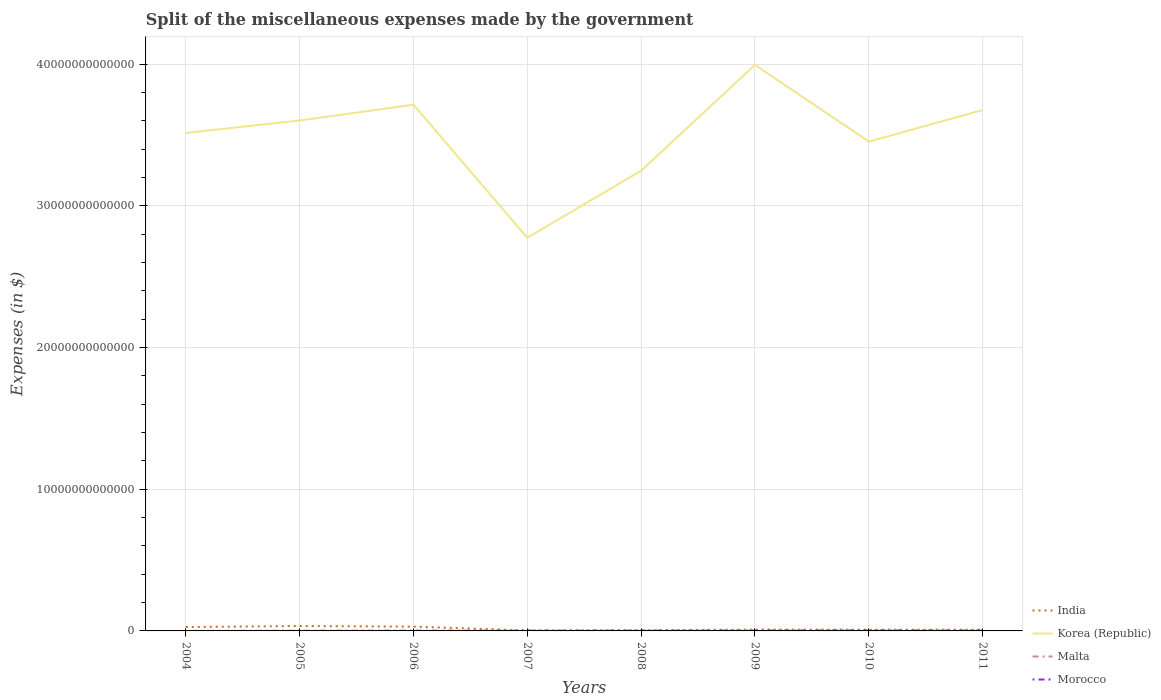How many different coloured lines are there?
Give a very brief answer. 4. Across all years, what is the maximum miscellaneous expenses made by the government in Korea (Republic)?
Give a very brief answer. 2.77e+13. In which year was the miscellaneous expenses made by the government in Korea (Republic) maximum?
Give a very brief answer. 2007. What is the total miscellaneous expenses made by the government in Malta in the graph?
Your answer should be compact. 2.40e+08. What is the difference between the highest and the second highest miscellaneous expenses made by the government in Malta?
Offer a very short reply. 2.79e+08. What is the difference between two consecutive major ticks on the Y-axis?
Your answer should be very brief. 1.00e+13. Does the graph contain any zero values?
Give a very brief answer. No. Where does the legend appear in the graph?
Ensure brevity in your answer.  Bottom right. How are the legend labels stacked?
Your answer should be very brief. Vertical. What is the title of the graph?
Offer a terse response. Split of the miscellaneous expenses made by the government. Does "Israel" appear as one of the legend labels in the graph?
Offer a terse response. No. What is the label or title of the Y-axis?
Offer a terse response. Expenses (in $). What is the Expenses (in $) in India in 2004?
Give a very brief answer. 2.73e+11. What is the Expenses (in $) of Korea (Republic) in 2004?
Provide a succinct answer. 3.51e+13. What is the Expenses (in $) in Malta in 2004?
Keep it short and to the point. 4.60e+08. What is the Expenses (in $) of Morocco in 2004?
Your answer should be very brief. 9.22e+08. What is the Expenses (in $) of India in 2005?
Your answer should be very brief. 3.47e+11. What is the Expenses (in $) in Korea (Republic) in 2005?
Provide a succinct answer. 3.60e+13. What is the Expenses (in $) of Malta in 2005?
Your response must be concise. 4.38e+08. What is the Expenses (in $) of Morocco in 2005?
Ensure brevity in your answer.  8.26e+09. What is the Expenses (in $) in India in 2006?
Provide a short and direct response. 3.02e+11. What is the Expenses (in $) of Korea (Republic) in 2006?
Make the answer very short. 3.71e+13. What is the Expenses (in $) of Malta in 2006?
Offer a very short reply. 4.76e+08. What is the Expenses (in $) in Morocco in 2006?
Give a very brief answer. 1.48e+1. What is the Expenses (in $) of India in 2007?
Make the answer very short. 3.86e+1. What is the Expenses (in $) of Korea (Republic) in 2007?
Your answer should be very brief. 2.77e+13. What is the Expenses (in $) in Malta in 2007?
Ensure brevity in your answer.  4.99e+08. What is the Expenses (in $) of Morocco in 2007?
Your answer should be compact. 1.71e+1. What is the Expenses (in $) of India in 2008?
Keep it short and to the point. 5.13e+1. What is the Expenses (in $) in Korea (Republic) in 2008?
Your answer should be very brief. 3.25e+13. What is the Expenses (in $) in Malta in 2008?
Ensure brevity in your answer.  2.20e+08. What is the Expenses (in $) in Morocco in 2008?
Provide a short and direct response. 1.90e+1. What is the Expenses (in $) of India in 2009?
Keep it short and to the point. 9.36e+1. What is the Expenses (in $) of Korea (Republic) in 2009?
Provide a succinct answer. 3.99e+13. What is the Expenses (in $) in Malta in 2009?
Offer a very short reply. 2.47e+08. What is the Expenses (in $) in Morocco in 2009?
Provide a succinct answer. 2.65e+1. What is the Expenses (in $) in India in 2010?
Make the answer very short. 8.96e+1. What is the Expenses (in $) in Korea (Republic) in 2010?
Provide a short and direct response. 3.45e+13. What is the Expenses (in $) in Malta in 2010?
Your answer should be compact. 3.06e+08. What is the Expenses (in $) of Morocco in 2010?
Make the answer very short. 3.37e+1. What is the Expenses (in $) of India in 2011?
Your response must be concise. 8.96e+1. What is the Expenses (in $) of Korea (Republic) in 2011?
Your response must be concise. 3.68e+13. What is the Expenses (in $) of Malta in 2011?
Offer a very short reply. 2.55e+08. What is the Expenses (in $) in Morocco in 2011?
Your answer should be very brief. 2.68e+1. Across all years, what is the maximum Expenses (in $) of India?
Give a very brief answer. 3.47e+11. Across all years, what is the maximum Expenses (in $) in Korea (Republic)?
Ensure brevity in your answer.  3.99e+13. Across all years, what is the maximum Expenses (in $) of Malta?
Make the answer very short. 4.99e+08. Across all years, what is the maximum Expenses (in $) in Morocco?
Provide a short and direct response. 3.37e+1. Across all years, what is the minimum Expenses (in $) of India?
Provide a short and direct response. 3.86e+1. Across all years, what is the minimum Expenses (in $) in Korea (Republic)?
Offer a terse response. 2.77e+13. Across all years, what is the minimum Expenses (in $) in Malta?
Ensure brevity in your answer.  2.20e+08. Across all years, what is the minimum Expenses (in $) of Morocco?
Ensure brevity in your answer.  9.22e+08. What is the total Expenses (in $) of India in the graph?
Your answer should be compact. 1.29e+12. What is the total Expenses (in $) in Korea (Republic) in the graph?
Your answer should be very brief. 2.80e+14. What is the total Expenses (in $) of Malta in the graph?
Keep it short and to the point. 2.90e+09. What is the total Expenses (in $) in Morocco in the graph?
Keep it short and to the point. 1.47e+11. What is the difference between the Expenses (in $) in India in 2004 and that in 2005?
Offer a terse response. -7.41e+1. What is the difference between the Expenses (in $) of Korea (Republic) in 2004 and that in 2005?
Provide a succinct answer. -8.79e+11. What is the difference between the Expenses (in $) of Malta in 2004 and that in 2005?
Make the answer very short. 2.16e+07. What is the difference between the Expenses (in $) of Morocco in 2004 and that in 2005?
Offer a terse response. -7.33e+09. What is the difference between the Expenses (in $) in India in 2004 and that in 2006?
Offer a very short reply. -2.88e+1. What is the difference between the Expenses (in $) of Korea (Republic) in 2004 and that in 2006?
Your answer should be very brief. -1.99e+12. What is the difference between the Expenses (in $) in Malta in 2004 and that in 2006?
Make the answer very short. -1.55e+07. What is the difference between the Expenses (in $) of Morocco in 2004 and that in 2006?
Offer a terse response. -1.38e+1. What is the difference between the Expenses (in $) in India in 2004 and that in 2007?
Make the answer very short. 2.35e+11. What is the difference between the Expenses (in $) of Korea (Republic) in 2004 and that in 2007?
Your answer should be compact. 7.40e+12. What is the difference between the Expenses (in $) in Malta in 2004 and that in 2007?
Keep it short and to the point. -3.93e+07. What is the difference between the Expenses (in $) of Morocco in 2004 and that in 2007?
Your answer should be very brief. -1.61e+1. What is the difference between the Expenses (in $) in India in 2004 and that in 2008?
Keep it short and to the point. 2.22e+11. What is the difference between the Expenses (in $) in Korea (Republic) in 2004 and that in 2008?
Your answer should be very brief. 2.66e+12. What is the difference between the Expenses (in $) in Malta in 2004 and that in 2008?
Provide a succinct answer. 2.40e+08. What is the difference between the Expenses (in $) in Morocco in 2004 and that in 2008?
Your answer should be very brief. -1.81e+1. What is the difference between the Expenses (in $) of India in 2004 and that in 2009?
Your answer should be compact. 1.80e+11. What is the difference between the Expenses (in $) in Korea (Republic) in 2004 and that in 2009?
Give a very brief answer. -4.80e+12. What is the difference between the Expenses (in $) of Malta in 2004 and that in 2009?
Your response must be concise. 2.13e+08. What is the difference between the Expenses (in $) in Morocco in 2004 and that in 2009?
Ensure brevity in your answer.  -2.56e+1. What is the difference between the Expenses (in $) of India in 2004 and that in 2010?
Offer a terse response. 1.84e+11. What is the difference between the Expenses (in $) in Korea (Republic) in 2004 and that in 2010?
Ensure brevity in your answer.  6.11e+11. What is the difference between the Expenses (in $) in Malta in 2004 and that in 2010?
Your answer should be compact. 1.54e+08. What is the difference between the Expenses (in $) in Morocco in 2004 and that in 2010?
Provide a short and direct response. -3.27e+1. What is the difference between the Expenses (in $) in India in 2004 and that in 2011?
Provide a short and direct response. 1.84e+11. What is the difference between the Expenses (in $) in Korea (Republic) in 2004 and that in 2011?
Offer a terse response. -1.62e+12. What is the difference between the Expenses (in $) in Malta in 2004 and that in 2011?
Keep it short and to the point. 2.05e+08. What is the difference between the Expenses (in $) in Morocco in 2004 and that in 2011?
Keep it short and to the point. -2.59e+1. What is the difference between the Expenses (in $) in India in 2005 and that in 2006?
Provide a short and direct response. 4.53e+1. What is the difference between the Expenses (in $) of Korea (Republic) in 2005 and that in 2006?
Your answer should be compact. -1.12e+12. What is the difference between the Expenses (in $) of Malta in 2005 and that in 2006?
Keep it short and to the point. -3.71e+07. What is the difference between the Expenses (in $) in Morocco in 2005 and that in 2006?
Your answer should be very brief. -6.52e+09. What is the difference between the Expenses (in $) in India in 2005 and that in 2007?
Make the answer very short. 3.09e+11. What is the difference between the Expenses (in $) in Korea (Republic) in 2005 and that in 2007?
Keep it short and to the point. 8.28e+12. What is the difference between the Expenses (in $) in Malta in 2005 and that in 2007?
Your answer should be compact. -6.09e+07. What is the difference between the Expenses (in $) in Morocco in 2005 and that in 2007?
Keep it short and to the point. -8.81e+09. What is the difference between the Expenses (in $) in India in 2005 and that in 2008?
Ensure brevity in your answer.  2.96e+11. What is the difference between the Expenses (in $) in Korea (Republic) in 2005 and that in 2008?
Your answer should be compact. 3.54e+12. What is the difference between the Expenses (in $) in Malta in 2005 and that in 2008?
Provide a succinct answer. 2.18e+08. What is the difference between the Expenses (in $) of Morocco in 2005 and that in 2008?
Ensure brevity in your answer.  -1.08e+1. What is the difference between the Expenses (in $) in India in 2005 and that in 2009?
Offer a terse response. 2.54e+11. What is the difference between the Expenses (in $) of Korea (Republic) in 2005 and that in 2009?
Your answer should be compact. -3.93e+12. What is the difference between the Expenses (in $) in Malta in 2005 and that in 2009?
Offer a very short reply. 1.92e+08. What is the difference between the Expenses (in $) of Morocco in 2005 and that in 2009?
Provide a short and direct response. -1.82e+1. What is the difference between the Expenses (in $) of India in 2005 and that in 2010?
Provide a succinct answer. 2.58e+11. What is the difference between the Expenses (in $) of Korea (Republic) in 2005 and that in 2010?
Make the answer very short. 1.49e+12. What is the difference between the Expenses (in $) in Malta in 2005 and that in 2010?
Ensure brevity in your answer.  1.33e+08. What is the difference between the Expenses (in $) of Morocco in 2005 and that in 2010?
Give a very brief answer. -2.54e+1. What is the difference between the Expenses (in $) of India in 2005 and that in 2011?
Your answer should be compact. 2.58e+11. What is the difference between the Expenses (in $) in Korea (Republic) in 2005 and that in 2011?
Provide a short and direct response. -7.41e+11. What is the difference between the Expenses (in $) of Malta in 2005 and that in 2011?
Your response must be concise. 1.84e+08. What is the difference between the Expenses (in $) of Morocco in 2005 and that in 2011?
Make the answer very short. -1.86e+1. What is the difference between the Expenses (in $) in India in 2006 and that in 2007?
Provide a short and direct response. 2.64e+11. What is the difference between the Expenses (in $) of Korea (Republic) in 2006 and that in 2007?
Provide a short and direct response. 9.39e+12. What is the difference between the Expenses (in $) of Malta in 2006 and that in 2007?
Your answer should be very brief. -2.38e+07. What is the difference between the Expenses (in $) in Morocco in 2006 and that in 2007?
Your answer should be compact. -2.29e+09. What is the difference between the Expenses (in $) of India in 2006 and that in 2008?
Your answer should be compact. 2.51e+11. What is the difference between the Expenses (in $) of Korea (Republic) in 2006 and that in 2008?
Your answer should be very brief. 4.66e+12. What is the difference between the Expenses (in $) in Malta in 2006 and that in 2008?
Provide a short and direct response. 2.55e+08. What is the difference between the Expenses (in $) of Morocco in 2006 and that in 2008?
Provide a short and direct response. -4.27e+09. What is the difference between the Expenses (in $) in India in 2006 and that in 2009?
Your answer should be very brief. 2.09e+11. What is the difference between the Expenses (in $) in Korea (Republic) in 2006 and that in 2009?
Your answer should be compact. -2.81e+12. What is the difference between the Expenses (in $) of Malta in 2006 and that in 2009?
Offer a terse response. 2.29e+08. What is the difference between the Expenses (in $) of Morocco in 2006 and that in 2009?
Make the answer very short. -1.17e+1. What is the difference between the Expenses (in $) in India in 2006 and that in 2010?
Your response must be concise. 2.13e+11. What is the difference between the Expenses (in $) of Korea (Republic) in 2006 and that in 2010?
Ensure brevity in your answer.  2.61e+12. What is the difference between the Expenses (in $) of Malta in 2006 and that in 2010?
Keep it short and to the point. 1.70e+08. What is the difference between the Expenses (in $) in Morocco in 2006 and that in 2010?
Keep it short and to the point. -1.89e+1. What is the difference between the Expenses (in $) in India in 2006 and that in 2011?
Provide a succinct answer. 2.13e+11. What is the difference between the Expenses (in $) of Korea (Republic) in 2006 and that in 2011?
Your answer should be compact. 3.75e+11. What is the difference between the Expenses (in $) in Malta in 2006 and that in 2011?
Your answer should be very brief. 2.21e+08. What is the difference between the Expenses (in $) of Morocco in 2006 and that in 2011?
Your answer should be compact. -1.21e+1. What is the difference between the Expenses (in $) in India in 2007 and that in 2008?
Give a very brief answer. -1.28e+1. What is the difference between the Expenses (in $) in Korea (Republic) in 2007 and that in 2008?
Your response must be concise. -4.73e+12. What is the difference between the Expenses (in $) of Malta in 2007 and that in 2008?
Offer a terse response. 2.79e+08. What is the difference between the Expenses (in $) of Morocco in 2007 and that in 2008?
Keep it short and to the point. -1.97e+09. What is the difference between the Expenses (in $) in India in 2007 and that in 2009?
Offer a terse response. -5.51e+1. What is the difference between the Expenses (in $) in Korea (Republic) in 2007 and that in 2009?
Offer a very short reply. -1.22e+13. What is the difference between the Expenses (in $) in Malta in 2007 and that in 2009?
Keep it short and to the point. 2.53e+08. What is the difference between the Expenses (in $) of Morocco in 2007 and that in 2009?
Give a very brief answer. -9.42e+09. What is the difference between the Expenses (in $) of India in 2007 and that in 2010?
Your answer should be very brief. -5.11e+1. What is the difference between the Expenses (in $) in Korea (Republic) in 2007 and that in 2010?
Give a very brief answer. -6.79e+12. What is the difference between the Expenses (in $) of Malta in 2007 and that in 2010?
Make the answer very short. 1.93e+08. What is the difference between the Expenses (in $) in Morocco in 2007 and that in 2010?
Offer a terse response. -1.66e+1. What is the difference between the Expenses (in $) in India in 2007 and that in 2011?
Offer a terse response. -5.11e+1. What is the difference between the Expenses (in $) of Korea (Republic) in 2007 and that in 2011?
Give a very brief answer. -9.02e+12. What is the difference between the Expenses (in $) of Malta in 2007 and that in 2011?
Ensure brevity in your answer.  2.45e+08. What is the difference between the Expenses (in $) of Morocco in 2007 and that in 2011?
Your answer should be very brief. -9.77e+09. What is the difference between the Expenses (in $) in India in 2008 and that in 2009?
Make the answer very short. -4.23e+1. What is the difference between the Expenses (in $) of Korea (Republic) in 2008 and that in 2009?
Offer a terse response. -7.47e+12. What is the difference between the Expenses (in $) in Malta in 2008 and that in 2009?
Offer a terse response. -2.64e+07. What is the difference between the Expenses (in $) of Morocco in 2008 and that in 2009?
Provide a succinct answer. -7.44e+09. What is the difference between the Expenses (in $) of India in 2008 and that in 2010?
Your answer should be very brief. -3.83e+1. What is the difference between the Expenses (in $) of Korea (Republic) in 2008 and that in 2010?
Give a very brief answer. -2.05e+12. What is the difference between the Expenses (in $) in Malta in 2008 and that in 2010?
Offer a terse response. -8.56e+07. What is the difference between the Expenses (in $) of Morocco in 2008 and that in 2010?
Provide a short and direct response. -1.46e+1. What is the difference between the Expenses (in $) in India in 2008 and that in 2011?
Keep it short and to the point. -3.83e+1. What is the difference between the Expenses (in $) of Korea (Republic) in 2008 and that in 2011?
Provide a short and direct response. -4.28e+12. What is the difference between the Expenses (in $) in Malta in 2008 and that in 2011?
Make the answer very short. -3.44e+07. What is the difference between the Expenses (in $) in Morocco in 2008 and that in 2011?
Give a very brief answer. -7.79e+09. What is the difference between the Expenses (in $) in India in 2009 and that in 2010?
Keep it short and to the point. 4.01e+09. What is the difference between the Expenses (in $) in Korea (Republic) in 2009 and that in 2010?
Offer a terse response. 5.41e+12. What is the difference between the Expenses (in $) of Malta in 2009 and that in 2010?
Keep it short and to the point. -5.92e+07. What is the difference between the Expenses (in $) in Morocco in 2009 and that in 2010?
Your answer should be compact. -7.18e+09. What is the difference between the Expenses (in $) in India in 2009 and that in 2011?
Your response must be concise. 4.01e+09. What is the difference between the Expenses (in $) of Korea (Republic) in 2009 and that in 2011?
Make the answer very short. 3.18e+12. What is the difference between the Expenses (in $) of Malta in 2009 and that in 2011?
Provide a succinct answer. -8.00e+06. What is the difference between the Expenses (in $) of Morocco in 2009 and that in 2011?
Your answer should be very brief. -3.48e+08. What is the difference between the Expenses (in $) in India in 2010 and that in 2011?
Keep it short and to the point. 0. What is the difference between the Expenses (in $) of Korea (Republic) in 2010 and that in 2011?
Give a very brief answer. -2.23e+12. What is the difference between the Expenses (in $) in Malta in 2010 and that in 2011?
Keep it short and to the point. 5.12e+07. What is the difference between the Expenses (in $) of Morocco in 2010 and that in 2011?
Ensure brevity in your answer.  6.84e+09. What is the difference between the Expenses (in $) in India in 2004 and the Expenses (in $) in Korea (Republic) in 2005?
Your answer should be compact. -3.57e+13. What is the difference between the Expenses (in $) in India in 2004 and the Expenses (in $) in Malta in 2005?
Make the answer very short. 2.73e+11. What is the difference between the Expenses (in $) in India in 2004 and the Expenses (in $) in Morocco in 2005?
Your answer should be compact. 2.65e+11. What is the difference between the Expenses (in $) of Korea (Republic) in 2004 and the Expenses (in $) of Malta in 2005?
Ensure brevity in your answer.  3.51e+13. What is the difference between the Expenses (in $) in Korea (Republic) in 2004 and the Expenses (in $) in Morocco in 2005?
Give a very brief answer. 3.51e+13. What is the difference between the Expenses (in $) in Malta in 2004 and the Expenses (in $) in Morocco in 2005?
Keep it short and to the point. -7.80e+09. What is the difference between the Expenses (in $) of India in 2004 and the Expenses (in $) of Korea (Republic) in 2006?
Make the answer very short. -3.69e+13. What is the difference between the Expenses (in $) in India in 2004 and the Expenses (in $) in Malta in 2006?
Make the answer very short. 2.73e+11. What is the difference between the Expenses (in $) of India in 2004 and the Expenses (in $) of Morocco in 2006?
Your answer should be very brief. 2.59e+11. What is the difference between the Expenses (in $) in Korea (Republic) in 2004 and the Expenses (in $) in Malta in 2006?
Your answer should be compact. 3.51e+13. What is the difference between the Expenses (in $) of Korea (Republic) in 2004 and the Expenses (in $) of Morocco in 2006?
Keep it short and to the point. 3.51e+13. What is the difference between the Expenses (in $) of Malta in 2004 and the Expenses (in $) of Morocco in 2006?
Offer a terse response. -1.43e+1. What is the difference between the Expenses (in $) in India in 2004 and the Expenses (in $) in Korea (Republic) in 2007?
Offer a terse response. -2.75e+13. What is the difference between the Expenses (in $) of India in 2004 and the Expenses (in $) of Malta in 2007?
Your answer should be compact. 2.73e+11. What is the difference between the Expenses (in $) of India in 2004 and the Expenses (in $) of Morocco in 2007?
Ensure brevity in your answer.  2.56e+11. What is the difference between the Expenses (in $) in Korea (Republic) in 2004 and the Expenses (in $) in Malta in 2007?
Keep it short and to the point. 3.51e+13. What is the difference between the Expenses (in $) in Korea (Republic) in 2004 and the Expenses (in $) in Morocco in 2007?
Give a very brief answer. 3.51e+13. What is the difference between the Expenses (in $) of Malta in 2004 and the Expenses (in $) of Morocco in 2007?
Your response must be concise. -1.66e+1. What is the difference between the Expenses (in $) of India in 2004 and the Expenses (in $) of Korea (Republic) in 2008?
Your answer should be very brief. -3.22e+13. What is the difference between the Expenses (in $) in India in 2004 and the Expenses (in $) in Malta in 2008?
Offer a terse response. 2.73e+11. What is the difference between the Expenses (in $) in India in 2004 and the Expenses (in $) in Morocco in 2008?
Your response must be concise. 2.54e+11. What is the difference between the Expenses (in $) of Korea (Republic) in 2004 and the Expenses (in $) of Malta in 2008?
Keep it short and to the point. 3.51e+13. What is the difference between the Expenses (in $) in Korea (Republic) in 2004 and the Expenses (in $) in Morocco in 2008?
Make the answer very short. 3.51e+13. What is the difference between the Expenses (in $) in Malta in 2004 and the Expenses (in $) in Morocco in 2008?
Ensure brevity in your answer.  -1.86e+1. What is the difference between the Expenses (in $) in India in 2004 and the Expenses (in $) in Korea (Republic) in 2009?
Provide a succinct answer. -3.97e+13. What is the difference between the Expenses (in $) in India in 2004 and the Expenses (in $) in Malta in 2009?
Give a very brief answer. 2.73e+11. What is the difference between the Expenses (in $) of India in 2004 and the Expenses (in $) of Morocco in 2009?
Provide a short and direct response. 2.47e+11. What is the difference between the Expenses (in $) of Korea (Republic) in 2004 and the Expenses (in $) of Malta in 2009?
Keep it short and to the point. 3.51e+13. What is the difference between the Expenses (in $) in Korea (Republic) in 2004 and the Expenses (in $) in Morocco in 2009?
Provide a short and direct response. 3.51e+13. What is the difference between the Expenses (in $) of Malta in 2004 and the Expenses (in $) of Morocco in 2009?
Your answer should be very brief. -2.60e+1. What is the difference between the Expenses (in $) in India in 2004 and the Expenses (in $) in Korea (Republic) in 2010?
Ensure brevity in your answer.  -3.43e+13. What is the difference between the Expenses (in $) in India in 2004 and the Expenses (in $) in Malta in 2010?
Offer a very short reply. 2.73e+11. What is the difference between the Expenses (in $) of India in 2004 and the Expenses (in $) of Morocco in 2010?
Your response must be concise. 2.40e+11. What is the difference between the Expenses (in $) in Korea (Republic) in 2004 and the Expenses (in $) in Malta in 2010?
Offer a terse response. 3.51e+13. What is the difference between the Expenses (in $) in Korea (Republic) in 2004 and the Expenses (in $) in Morocco in 2010?
Make the answer very short. 3.51e+13. What is the difference between the Expenses (in $) of Malta in 2004 and the Expenses (in $) of Morocco in 2010?
Offer a very short reply. -3.32e+1. What is the difference between the Expenses (in $) of India in 2004 and the Expenses (in $) of Korea (Republic) in 2011?
Your answer should be compact. -3.65e+13. What is the difference between the Expenses (in $) in India in 2004 and the Expenses (in $) in Malta in 2011?
Make the answer very short. 2.73e+11. What is the difference between the Expenses (in $) in India in 2004 and the Expenses (in $) in Morocco in 2011?
Offer a very short reply. 2.47e+11. What is the difference between the Expenses (in $) of Korea (Republic) in 2004 and the Expenses (in $) of Malta in 2011?
Keep it short and to the point. 3.51e+13. What is the difference between the Expenses (in $) in Korea (Republic) in 2004 and the Expenses (in $) in Morocco in 2011?
Provide a succinct answer. 3.51e+13. What is the difference between the Expenses (in $) in Malta in 2004 and the Expenses (in $) in Morocco in 2011?
Offer a very short reply. -2.64e+1. What is the difference between the Expenses (in $) in India in 2005 and the Expenses (in $) in Korea (Republic) in 2006?
Give a very brief answer. -3.68e+13. What is the difference between the Expenses (in $) of India in 2005 and the Expenses (in $) of Malta in 2006?
Your answer should be compact. 3.47e+11. What is the difference between the Expenses (in $) in India in 2005 and the Expenses (in $) in Morocco in 2006?
Offer a very short reply. 3.33e+11. What is the difference between the Expenses (in $) of Korea (Republic) in 2005 and the Expenses (in $) of Malta in 2006?
Make the answer very short. 3.60e+13. What is the difference between the Expenses (in $) of Korea (Republic) in 2005 and the Expenses (in $) of Morocco in 2006?
Ensure brevity in your answer.  3.60e+13. What is the difference between the Expenses (in $) of Malta in 2005 and the Expenses (in $) of Morocco in 2006?
Your response must be concise. -1.43e+1. What is the difference between the Expenses (in $) of India in 2005 and the Expenses (in $) of Korea (Republic) in 2007?
Your answer should be very brief. -2.74e+13. What is the difference between the Expenses (in $) of India in 2005 and the Expenses (in $) of Malta in 2007?
Give a very brief answer. 3.47e+11. What is the difference between the Expenses (in $) in India in 2005 and the Expenses (in $) in Morocco in 2007?
Give a very brief answer. 3.30e+11. What is the difference between the Expenses (in $) of Korea (Republic) in 2005 and the Expenses (in $) of Malta in 2007?
Make the answer very short. 3.60e+13. What is the difference between the Expenses (in $) in Korea (Republic) in 2005 and the Expenses (in $) in Morocco in 2007?
Offer a terse response. 3.60e+13. What is the difference between the Expenses (in $) in Malta in 2005 and the Expenses (in $) in Morocco in 2007?
Keep it short and to the point. -1.66e+1. What is the difference between the Expenses (in $) of India in 2005 and the Expenses (in $) of Korea (Republic) in 2008?
Offer a terse response. -3.21e+13. What is the difference between the Expenses (in $) of India in 2005 and the Expenses (in $) of Malta in 2008?
Your answer should be compact. 3.47e+11. What is the difference between the Expenses (in $) in India in 2005 and the Expenses (in $) in Morocco in 2008?
Provide a short and direct response. 3.28e+11. What is the difference between the Expenses (in $) in Korea (Republic) in 2005 and the Expenses (in $) in Malta in 2008?
Provide a succinct answer. 3.60e+13. What is the difference between the Expenses (in $) of Korea (Republic) in 2005 and the Expenses (in $) of Morocco in 2008?
Your answer should be very brief. 3.60e+13. What is the difference between the Expenses (in $) of Malta in 2005 and the Expenses (in $) of Morocco in 2008?
Make the answer very short. -1.86e+1. What is the difference between the Expenses (in $) in India in 2005 and the Expenses (in $) in Korea (Republic) in 2009?
Give a very brief answer. -3.96e+13. What is the difference between the Expenses (in $) of India in 2005 and the Expenses (in $) of Malta in 2009?
Provide a short and direct response. 3.47e+11. What is the difference between the Expenses (in $) of India in 2005 and the Expenses (in $) of Morocco in 2009?
Keep it short and to the point. 3.21e+11. What is the difference between the Expenses (in $) in Korea (Republic) in 2005 and the Expenses (in $) in Malta in 2009?
Provide a succinct answer. 3.60e+13. What is the difference between the Expenses (in $) of Korea (Republic) in 2005 and the Expenses (in $) of Morocco in 2009?
Your response must be concise. 3.60e+13. What is the difference between the Expenses (in $) in Malta in 2005 and the Expenses (in $) in Morocco in 2009?
Provide a short and direct response. -2.60e+1. What is the difference between the Expenses (in $) of India in 2005 and the Expenses (in $) of Korea (Republic) in 2010?
Offer a very short reply. -3.42e+13. What is the difference between the Expenses (in $) of India in 2005 and the Expenses (in $) of Malta in 2010?
Your answer should be compact. 3.47e+11. What is the difference between the Expenses (in $) of India in 2005 and the Expenses (in $) of Morocco in 2010?
Offer a terse response. 3.14e+11. What is the difference between the Expenses (in $) of Korea (Republic) in 2005 and the Expenses (in $) of Malta in 2010?
Offer a very short reply. 3.60e+13. What is the difference between the Expenses (in $) of Korea (Republic) in 2005 and the Expenses (in $) of Morocco in 2010?
Offer a terse response. 3.60e+13. What is the difference between the Expenses (in $) in Malta in 2005 and the Expenses (in $) in Morocco in 2010?
Offer a terse response. -3.32e+1. What is the difference between the Expenses (in $) in India in 2005 and the Expenses (in $) in Korea (Republic) in 2011?
Offer a very short reply. -3.64e+13. What is the difference between the Expenses (in $) in India in 2005 and the Expenses (in $) in Malta in 2011?
Your answer should be compact. 3.47e+11. What is the difference between the Expenses (in $) in India in 2005 and the Expenses (in $) in Morocco in 2011?
Give a very brief answer. 3.21e+11. What is the difference between the Expenses (in $) of Korea (Republic) in 2005 and the Expenses (in $) of Malta in 2011?
Make the answer very short. 3.60e+13. What is the difference between the Expenses (in $) in Korea (Republic) in 2005 and the Expenses (in $) in Morocco in 2011?
Give a very brief answer. 3.60e+13. What is the difference between the Expenses (in $) in Malta in 2005 and the Expenses (in $) in Morocco in 2011?
Keep it short and to the point. -2.64e+1. What is the difference between the Expenses (in $) of India in 2006 and the Expenses (in $) of Korea (Republic) in 2007?
Your response must be concise. -2.74e+13. What is the difference between the Expenses (in $) in India in 2006 and the Expenses (in $) in Malta in 2007?
Provide a short and direct response. 3.02e+11. What is the difference between the Expenses (in $) of India in 2006 and the Expenses (in $) of Morocco in 2007?
Make the answer very short. 2.85e+11. What is the difference between the Expenses (in $) of Korea (Republic) in 2006 and the Expenses (in $) of Malta in 2007?
Your answer should be very brief. 3.71e+13. What is the difference between the Expenses (in $) in Korea (Republic) in 2006 and the Expenses (in $) in Morocco in 2007?
Give a very brief answer. 3.71e+13. What is the difference between the Expenses (in $) of Malta in 2006 and the Expenses (in $) of Morocco in 2007?
Offer a terse response. -1.66e+1. What is the difference between the Expenses (in $) of India in 2006 and the Expenses (in $) of Korea (Republic) in 2008?
Make the answer very short. -3.22e+13. What is the difference between the Expenses (in $) in India in 2006 and the Expenses (in $) in Malta in 2008?
Ensure brevity in your answer.  3.02e+11. What is the difference between the Expenses (in $) in India in 2006 and the Expenses (in $) in Morocco in 2008?
Ensure brevity in your answer.  2.83e+11. What is the difference between the Expenses (in $) of Korea (Republic) in 2006 and the Expenses (in $) of Malta in 2008?
Your answer should be compact. 3.71e+13. What is the difference between the Expenses (in $) of Korea (Republic) in 2006 and the Expenses (in $) of Morocco in 2008?
Give a very brief answer. 3.71e+13. What is the difference between the Expenses (in $) in Malta in 2006 and the Expenses (in $) in Morocco in 2008?
Provide a succinct answer. -1.86e+1. What is the difference between the Expenses (in $) of India in 2006 and the Expenses (in $) of Korea (Republic) in 2009?
Offer a terse response. -3.96e+13. What is the difference between the Expenses (in $) of India in 2006 and the Expenses (in $) of Malta in 2009?
Keep it short and to the point. 3.02e+11. What is the difference between the Expenses (in $) of India in 2006 and the Expenses (in $) of Morocco in 2009?
Offer a terse response. 2.76e+11. What is the difference between the Expenses (in $) in Korea (Republic) in 2006 and the Expenses (in $) in Malta in 2009?
Keep it short and to the point. 3.71e+13. What is the difference between the Expenses (in $) in Korea (Republic) in 2006 and the Expenses (in $) in Morocco in 2009?
Your response must be concise. 3.71e+13. What is the difference between the Expenses (in $) of Malta in 2006 and the Expenses (in $) of Morocco in 2009?
Keep it short and to the point. -2.60e+1. What is the difference between the Expenses (in $) of India in 2006 and the Expenses (in $) of Korea (Republic) in 2010?
Make the answer very short. -3.42e+13. What is the difference between the Expenses (in $) of India in 2006 and the Expenses (in $) of Malta in 2010?
Make the answer very short. 3.02e+11. What is the difference between the Expenses (in $) in India in 2006 and the Expenses (in $) in Morocco in 2010?
Offer a very short reply. 2.69e+11. What is the difference between the Expenses (in $) in Korea (Republic) in 2006 and the Expenses (in $) in Malta in 2010?
Provide a succinct answer. 3.71e+13. What is the difference between the Expenses (in $) in Korea (Republic) in 2006 and the Expenses (in $) in Morocco in 2010?
Offer a terse response. 3.71e+13. What is the difference between the Expenses (in $) of Malta in 2006 and the Expenses (in $) of Morocco in 2010?
Make the answer very short. -3.32e+1. What is the difference between the Expenses (in $) in India in 2006 and the Expenses (in $) in Korea (Republic) in 2011?
Your answer should be compact. -3.65e+13. What is the difference between the Expenses (in $) of India in 2006 and the Expenses (in $) of Malta in 2011?
Your answer should be compact. 3.02e+11. What is the difference between the Expenses (in $) in India in 2006 and the Expenses (in $) in Morocco in 2011?
Your response must be concise. 2.75e+11. What is the difference between the Expenses (in $) of Korea (Republic) in 2006 and the Expenses (in $) of Malta in 2011?
Ensure brevity in your answer.  3.71e+13. What is the difference between the Expenses (in $) in Korea (Republic) in 2006 and the Expenses (in $) in Morocco in 2011?
Offer a terse response. 3.71e+13. What is the difference between the Expenses (in $) of Malta in 2006 and the Expenses (in $) of Morocco in 2011?
Ensure brevity in your answer.  -2.64e+1. What is the difference between the Expenses (in $) of India in 2007 and the Expenses (in $) of Korea (Republic) in 2008?
Provide a short and direct response. -3.24e+13. What is the difference between the Expenses (in $) in India in 2007 and the Expenses (in $) in Malta in 2008?
Your answer should be very brief. 3.83e+1. What is the difference between the Expenses (in $) of India in 2007 and the Expenses (in $) of Morocco in 2008?
Make the answer very short. 1.95e+1. What is the difference between the Expenses (in $) of Korea (Republic) in 2007 and the Expenses (in $) of Malta in 2008?
Provide a succinct answer. 2.77e+13. What is the difference between the Expenses (in $) in Korea (Republic) in 2007 and the Expenses (in $) in Morocco in 2008?
Offer a very short reply. 2.77e+13. What is the difference between the Expenses (in $) of Malta in 2007 and the Expenses (in $) of Morocco in 2008?
Provide a succinct answer. -1.85e+1. What is the difference between the Expenses (in $) in India in 2007 and the Expenses (in $) in Korea (Republic) in 2009?
Provide a short and direct response. -3.99e+13. What is the difference between the Expenses (in $) in India in 2007 and the Expenses (in $) in Malta in 2009?
Offer a terse response. 3.83e+1. What is the difference between the Expenses (in $) of India in 2007 and the Expenses (in $) of Morocco in 2009?
Your answer should be very brief. 1.21e+1. What is the difference between the Expenses (in $) of Korea (Republic) in 2007 and the Expenses (in $) of Malta in 2009?
Your response must be concise. 2.77e+13. What is the difference between the Expenses (in $) of Korea (Republic) in 2007 and the Expenses (in $) of Morocco in 2009?
Your response must be concise. 2.77e+13. What is the difference between the Expenses (in $) in Malta in 2007 and the Expenses (in $) in Morocco in 2009?
Ensure brevity in your answer.  -2.60e+1. What is the difference between the Expenses (in $) in India in 2007 and the Expenses (in $) in Korea (Republic) in 2010?
Make the answer very short. -3.45e+13. What is the difference between the Expenses (in $) of India in 2007 and the Expenses (in $) of Malta in 2010?
Provide a short and direct response. 3.82e+1. What is the difference between the Expenses (in $) in India in 2007 and the Expenses (in $) in Morocco in 2010?
Your response must be concise. 4.88e+09. What is the difference between the Expenses (in $) of Korea (Republic) in 2007 and the Expenses (in $) of Malta in 2010?
Your answer should be compact. 2.77e+13. What is the difference between the Expenses (in $) of Korea (Republic) in 2007 and the Expenses (in $) of Morocco in 2010?
Your response must be concise. 2.77e+13. What is the difference between the Expenses (in $) in Malta in 2007 and the Expenses (in $) in Morocco in 2010?
Your answer should be very brief. -3.32e+1. What is the difference between the Expenses (in $) of India in 2007 and the Expenses (in $) of Korea (Republic) in 2011?
Offer a terse response. -3.67e+13. What is the difference between the Expenses (in $) of India in 2007 and the Expenses (in $) of Malta in 2011?
Offer a very short reply. 3.83e+1. What is the difference between the Expenses (in $) of India in 2007 and the Expenses (in $) of Morocco in 2011?
Offer a terse response. 1.17e+1. What is the difference between the Expenses (in $) of Korea (Republic) in 2007 and the Expenses (in $) of Malta in 2011?
Your answer should be very brief. 2.77e+13. What is the difference between the Expenses (in $) of Korea (Republic) in 2007 and the Expenses (in $) of Morocco in 2011?
Give a very brief answer. 2.77e+13. What is the difference between the Expenses (in $) in Malta in 2007 and the Expenses (in $) in Morocco in 2011?
Your answer should be compact. -2.63e+1. What is the difference between the Expenses (in $) in India in 2008 and the Expenses (in $) in Korea (Republic) in 2009?
Your answer should be very brief. -3.99e+13. What is the difference between the Expenses (in $) in India in 2008 and the Expenses (in $) in Malta in 2009?
Offer a terse response. 5.11e+1. What is the difference between the Expenses (in $) of India in 2008 and the Expenses (in $) of Morocco in 2009?
Give a very brief answer. 2.48e+1. What is the difference between the Expenses (in $) of Korea (Republic) in 2008 and the Expenses (in $) of Malta in 2009?
Offer a terse response. 3.25e+13. What is the difference between the Expenses (in $) of Korea (Republic) in 2008 and the Expenses (in $) of Morocco in 2009?
Provide a succinct answer. 3.25e+13. What is the difference between the Expenses (in $) of Malta in 2008 and the Expenses (in $) of Morocco in 2009?
Your answer should be very brief. -2.63e+1. What is the difference between the Expenses (in $) of India in 2008 and the Expenses (in $) of Korea (Republic) in 2010?
Provide a short and direct response. -3.45e+13. What is the difference between the Expenses (in $) in India in 2008 and the Expenses (in $) in Malta in 2010?
Offer a terse response. 5.10e+1. What is the difference between the Expenses (in $) in India in 2008 and the Expenses (in $) in Morocco in 2010?
Provide a short and direct response. 1.76e+1. What is the difference between the Expenses (in $) in Korea (Republic) in 2008 and the Expenses (in $) in Malta in 2010?
Your answer should be very brief. 3.25e+13. What is the difference between the Expenses (in $) in Korea (Republic) in 2008 and the Expenses (in $) in Morocco in 2010?
Your answer should be compact. 3.24e+13. What is the difference between the Expenses (in $) of Malta in 2008 and the Expenses (in $) of Morocco in 2010?
Keep it short and to the point. -3.34e+1. What is the difference between the Expenses (in $) of India in 2008 and the Expenses (in $) of Korea (Republic) in 2011?
Offer a very short reply. -3.67e+13. What is the difference between the Expenses (in $) in India in 2008 and the Expenses (in $) in Malta in 2011?
Provide a short and direct response. 5.11e+1. What is the difference between the Expenses (in $) in India in 2008 and the Expenses (in $) in Morocco in 2011?
Offer a terse response. 2.45e+1. What is the difference between the Expenses (in $) of Korea (Republic) in 2008 and the Expenses (in $) of Malta in 2011?
Ensure brevity in your answer.  3.25e+13. What is the difference between the Expenses (in $) of Korea (Republic) in 2008 and the Expenses (in $) of Morocco in 2011?
Give a very brief answer. 3.25e+13. What is the difference between the Expenses (in $) in Malta in 2008 and the Expenses (in $) in Morocco in 2011?
Make the answer very short. -2.66e+1. What is the difference between the Expenses (in $) of India in 2009 and the Expenses (in $) of Korea (Republic) in 2010?
Offer a terse response. -3.44e+13. What is the difference between the Expenses (in $) of India in 2009 and the Expenses (in $) of Malta in 2010?
Your answer should be very brief. 9.33e+1. What is the difference between the Expenses (in $) of India in 2009 and the Expenses (in $) of Morocco in 2010?
Offer a very short reply. 6.00e+1. What is the difference between the Expenses (in $) in Korea (Republic) in 2009 and the Expenses (in $) in Malta in 2010?
Keep it short and to the point. 3.99e+13. What is the difference between the Expenses (in $) of Korea (Republic) in 2009 and the Expenses (in $) of Morocco in 2010?
Provide a succinct answer. 3.99e+13. What is the difference between the Expenses (in $) in Malta in 2009 and the Expenses (in $) in Morocco in 2010?
Your answer should be compact. -3.34e+1. What is the difference between the Expenses (in $) of India in 2009 and the Expenses (in $) of Korea (Republic) in 2011?
Offer a terse response. -3.67e+13. What is the difference between the Expenses (in $) of India in 2009 and the Expenses (in $) of Malta in 2011?
Offer a very short reply. 9.34e+1. What is the difference between the Expenses (in $) of India in 2009 and the Expenses (in $) of Morocco in 2011?
Provide a succinct answer. 6.68e+1. What is the difference between the Expenses (in $) in Korea (Republic) in 2009 and the Expenses (in $) in Malta in 2011?
Your response must be concise. 3.99e+13. What is the difference between the Expenses (in $) of Korea (Republic) in 2009 and the Expenses (in $) of Morocco in 2011?
Your answer should be very brief. 3.99e+13. What is the difference between the Expenses (in $) of Malta in 2009 and the Expenses (in $) of Morocco in 2011?
Offer a very short reply. -2.66e+1. What is the difference between the Expenses (in $) in India in 2010 and the Expenses (in $) in Korea (Republic) in 2011?
Give a very brief answer. -3.67e+13. What is the difference between the Expenses (in $) of India in 2010 and the Expenses (in $) of Malta in 2011?
Your answer should be compact. 8.94e+1. What is the difference between the Expenses (in $) in India in 2010 and the Expenses (in $) in Morocco in 2011?
Your answer should be very brief. 6.28e+1. What is the difference between the Expenses (in $) of Korea (Republic) in 2010 and the Expenses (in $) of Malta in 2011?
Offer a terse response. 3.45e+13. What is the difference between the Expenses (in $) of Korea (Republic) in 2010 and the Expenses (in $) of Morocco in 2011?
Ensure brevity in your answer.  3.45e+13. What is the difference between the Expenses (in $) of Malta in 2010 and the Expenses (in $) of Morocco in 2011?
Offer a terse response. -2.65e+1. What is the average Expenses (in $) in India per year?
Offer a very short reply. 1.61e+11. What is the average Expenses (in $) in Korea (Republic) per year?
Offer a very short reply. 3.50e+13. What is the average Expenses (in $) of Malta per year?
Your answer should be very brief. 3.63e+08. What is the average Expenses (in $) in Morocco per year?
Give a very brief answer. 1.84e+1. In the year 2004, what is the difference between the Expenses (in $) in India and Expenses (in $) in Korea (Republic)?
Provide a short and direct response. -3.49e+13. In the year 2004, what is the difference between the Expenses (in $) in India and Expenses (in $) in Malta?
Offer a terse response. 2.73e+11. In the year 2004, what is the difference between the Expenses (in $) in India and Expenses (in $) in Morocco?
Provide a short and direct response. 2.72e+11. In the year 2004, what is the difference between the Expenses (in $) of Korea (Republic) and Expenses (in $) of Malta?
Give a very brief answer. 3.51e+13. In the year 2004, what is the difference between the Expenses (in $) of Korea (Republic) and Expenses (in $) of Morocco?
Provide a succinct answer. 3.51e+13. In the year 2004, what is the difference between the Expenses (in $) in Malta and Expenses (in $) in Morocco?
Your answer should be very brief. -4.61e+08. In the year 2005, what is the difference between the Expenses (in $) of India and Expenses (in $) of Korea (Republic)?
Provide a short and direct response. -3.57e+13. In the year 2005, what is the difference between the Expenses (in $) in India and Expenses (in $) in Malta?
Your response must be concise. 3.47e+11. In the year 2005, what is the difference between the Expenses (in $) in India and Expenses (in $) in Morocco?
Your answer should be very brief. 3.39e+11. In the year 2005, what is the difference between the Expenses (in $) of Korea (Republic) and Expenses (in $) of Malta?
Provide a short and direct response. 3.60e+13. In the year 2005, what is the difference between the Expenses (in $) in Korea (Republic) and Expenses (in $) in Morocco?
Your response must be concise. 3.60e+13. In the year 2005, what is the difference between the Expenses (in $) of Malta and Expenses (in $) of Morocco?
Your answer should be very brief. -7.82e+09. In the year 2006, what is the difference between the Expenses (in $) of India and Expenses (in $) of Korea (Republic)?
Make the answer very short. -3.68e+13. In the year 2006, what is the difference between the Expenses (in $) in India and Expenses (in $) in Malta?
Offer a very short reply. 3.02e+11. In the year 2006, what is the difference between the Expenses (in $) in India and Expenses (in $) in Morocco?
Your response must be concise. 2.87e+11. In the year 2006, what is the difference between the Expenses (in $) in Korea (Republic) and Expenses (in $) in Malta?
Provide a succinct answer. 3.71e+13. In the year 2006, what is the difference between the Expenses (in $) in Korea (Republic) and Expenses (in $) in Morocco?
Ensure brevity in your answer.  3.71e+13. In the year 2006, what is the difference between the Expenses (in $) in Malta and Expenses (in $) in Morocco?
Provide a succinct answer. -1.43e+1. In the year 2007, what is the difference between the Expenses (in $) of India and Expenses (in $) of Korea (Republic)?
Provide a short and direct response. -2.77e+13. In the year 2007, what is the difference between the Expenses (in $) of India and Expenses (in $) of Malta?
Keep it short and to the point. 3.81e+1. In the year 2007, what is the difference between the Expenses (in $) of India and Expenses (in $) of Morocco?
Give a very brief answer. 2.15e+1. In the year 2007, what is the difference between the Expenses (in $) in Korea (Republic) and Expenses (in $) in Malta?
Keep it short and to the point. 2.77e+13. In the year 2007, what is the difference between the Expenses (in $) in Korea (Republic) and Expenses (in $) in Morocco?
Keep it short and to the point. 2.77e+13. In the year 2007, what is the difference between the Expenses (in $) of Malta and Expenses (in $) of Morocco?
Offer a terse response. -1.66e+1. In the year 2008, what is the difference between the Expenses (in $) of India and Expenses (in $) of Korea (Republic)?
Provide a succinct answer. -3.24e+13. In the year 2008, what is the difference between the Expenses (in $) in India and Expenses (in $) in Malta?
Provide a succinct answer. 5.11e+1. In the year 2008, what is the difference between the Expenses (in $) in India and Expenses (in $) in Morocco?
Your answer should be very brief. 3.23e+1. In the year 2008, what is the difference between the Expenses (in $) of Korea (Republic) and Expenses (in $) of Malta?
Provide a succinct answer. 3.25e+13. In the year 2008, what is the difference between the Expenses (in $) in Korea (Republic) and Expenses (in $) in Morocco?
Make the answer very short. 3.25e+13. In the year 2008, what is the difference between the Expenses (in $) of Malta and Expenses (in $) of Morocco?
Make the answer very short. -1.88e+1. In the year 2009, what is the difference between the Expenses (in $) in India and Expenses (in $) in Korea (Republic)?
Provide a succinct answer. -3.99e+13. In the year 2009, what is the difference between the Expenses (in $) in India and Expenses (in $) in Malta?
Offer a very short reply. 9.34e+1. In the year 2009, what is the difference between the Expenses (in $) in India and Expenses (in $) in Morocco?
Your answer should be very brief. 6.72e+1. In the year 2009, what is the difference between the Expenses (in $) in Korea (Republic) and Expenses (in $) in Malta?
Your answer should be compact. 3.99e+13. In the year 2009, what is the difference between the Expenses (in $) of Korea (Republic) and Expenses (in $) of Morocco?
Make the answer very short. 3.99e+13. In the year 2009, what is the difference between the Expenses (in $) of Malta and Expenses (in $) of Morocco?
Provide a short and direct response. -2.62e+1. In the year 2010, what is the difference between the Expenses (in $) of India and Expenses (in $) of Korea (Republic)?
Make the answer very short. -3.44e+13. In the year 2010, what is the difference between the Expenses (in $) in India and Expenses (in $) in Malta?
Make the answer very short. 8.93e+1. In the year 2010, what is the difference between the Expenses (in $) in India and Expenses (in $) in Morocco?
Your response must be concise. 5.60e+1. In the year 2010, what is the difference between the Expenses (in $) of Korea (Republic) and Expenses (in $) of Malta?
Make the answer very short. 3.45e+13. In the year 2010, what is the difference between the Expenses (in $) of Korea (Republic) and Expenses (in $) of Morocco?
Your answer should be very brief. 3.45e+13. In the year 2010, what is the difference between the Expenses (in $) in Malta and Expenses (in $) in Morocco?
Offer a terse response. -3.34e+1. In the year 2011, what is the difference between the Expenses (in $) of India and Expenses (in $) of Korea (Republic)?
Your answer should be very brief. -3.67e+13. In the year 2011, what is the difference between the Expenses (in $) of India and Expenses (in $) of Malta?
Your answer should be compact. 8.94e+1. In the year 2011, what is the difference between the Expenses (in $) of India and Expenses (in $) of Morocco?
Keep it short and to the point. 6.28e+1. In the year 2011, what is the difference between the Expenses (in $) in Korea (Republic) and Expenses (in $) in Malta?
Your answer should be very brief. 3.68e+13. In the year 2011, what is the difference between the Expenses (in $) of Korea (Republic) and Expenses (in $) of Morocco?
Offer a very short reply. 3.67e+13. In the year 2011, what is the difference between the Expenses (in $) in Malta and Expenses (in $) in Morocco?
Provide a short and direct response. -2.66e+1. What is the ratio of the Expenses (in $) in India in 2004 to that in 2005?
Offer a terse response. 0.79. What is the ratio of the Expenses (in $) of Korea (Republic) in 2004 to that in 2005?
Your response must be concise. 0.98. What is the ratio of the Expenses (in $) in Malta in 2004 to that in 2005?
Offer a very short reply. 1.05. What is the ratio of the Expenses (in $) in Morocco in 2004 to that in 2005?
Provide a succinct answer. 0.11. What is the ratio of the Expenses (in $) of India in 2004 to that in 2006?
Offer a terse response. 0.9. What is the ratio of the Expenses (in $) of Korea (Republic) in 2004 to that in 2006?
Provide a short and direct response. 0.95. What is the ratio of the Expenses (in $) in Malta in 2004 to that in 2006?
Ensure brevity in your answer.  0.97. What is the ratio of the Expenses (in $) of Morocco in 2004 to that in 2006?
Provide a succinct answer. 0.06. What is the ratio of the Expenses (in $) in India in 2004 to that in 2007?
Provide a succinct answer. 7.09. What is the ratio of the Expenses (in $) of Korea (Republic) in 2004 to that in 2007?
Your answer should be very brief. 1.27. What is the ratio of the Expenses (in $) of Malta in 2004 to that in 2007?
Ensure brevity in your answer.  0.92. What is the ratio of the Expenses (in $) of Morocco in 2004 to that in 2007?
Give a very brief answer. 0.05. What is the ratio of the Expenses (in $) in India in 2004 to that in 2008?
Offer a very short reply. 5.33. What is the ratio of the Expenses (in $) of Korea (Republic) in 2004 to that in 2008?
Provide a short and direct response. 1.08. What is the ratio of the Expenses (in $) of Malta in 2004 to that in 2008?
Ensure brevity in your answer.  2.09. What is the ratio of the Expenses (in $) of Morocco in 2004 to that in 2008?
Give a very brief answer. 0.05. What is the ratio of the Expenses (in $) of India in 2004 to that in 2009?
Give a very brief answer. 2.92. What is the ratio of the Expenses (in $) of Korea (Republic) in 2004 to that in 2009?
Your answer should be compact. 0.88. What is the ratio of the Expenses (in $) in Malta in 2004 to that in 2009?
Offer a very short reply. 1.86. What is the ratio of the Expenses (in $) of Morocco in 2004 to that in 2009?
Your answer should be very brief. 0.03. What is the ratio of the Expenses (in $) in India in 2004 to that in 2010?
Provide a short and direct response. 3.05. What is the ratio of the Expenses (in $) in Korea (Republic) in 2004 to that in 2010?
Provide a short and direct response. 1.02. What is the ratio of the Expenses (in $) in Malta in 2004 to that in 2010?
Your answer should be very brief. 1.5. What is the ratio of the Expenses (in $) of Morocco in 2004 to that in 2010?
Provide a succinct answer. 0.03. What is the ratio of the Expenses (in $) in India in 2004 to that in 2011?
Your answer should be very brief. 3.05. What is the ratio of the Expenses (in $) in Korea (Republic) in 2004 to that in 2011?
Your response must be concise. 0.96. What is the ratio of the Expenses (in $) in Malta in 2004 to that in 2011?
Make the answer very short. 1.81. What is the ratio of the Expenses (in $) in Morocco in 2004 to that in 2011?
Give a very brief answer. 0.03. What is the ratio of the Expenses (in $) in India in 2005 to that in 2006?
Make the answer very short. 1.15. What is the ratio of the Expenses (in $) of Malta in 2005 to that in 2006?
Your response must be concise. 0.92. What is the ratio of the Expenses (in $) in Morocco in 2005 to that in 2006?
Provide a short and direct response. 0.56. What is the ratio of the Expenses (in $) in India in 2005 to that in 2007?
Provide a succinct answer. 9.01. What is the ratio of the Expenses (in $) of Korea (Republic) in 2005 to that in 2007?
Your response must be concise. 1.3. What is the ratio of the Expenses (in $) of Malta in 2005 to that in 2007?
Your answer should be compact. 0.88. What is the ratio of the Expenses (in $) of Morocco in 2005 to that in 2007?
Keep it short and to the point. 0.48. What is the ratio of the Expenses (in $) of India in 2005 to that in 2008?
Your answer should be compact. 6.77. What is the ratio of the Expenses (in $) of Korea (Republic) in 2005 to that in 2008?
Your answer should be compact. 1.11. What is the ratio of the Expenses (in $) in Malta in 2005 to that in 2008?
Provide a short and direct response. 1.99. What is the ratio of the Expenses (in $) of Morocco in 2005 to that in 2008?
Give a very brief answer. 0.43. What is the ratio of the Expenses (in $) in India in 2005 to that in 2009?
Your response must be concise. 3.71. What is the ratio of the Expenses (in $) in Korea (Republic) in 2005 to that in 2009?
Give a very brief answer. 0.9. What is the ratio of the Expenses (in $) of Malta in 2005 to that in 2009?
Your answer should be very brief. 1.78. What is the ratio of the Expenses (in $) in Morocco in 2005 to that in 2009?
Keep it short and to the point. 0.31. What is the ratio of the Expenses (in $) of India in 2005 to that in 2010?
Ensure brevity in your answer.  3.88. What is the ratio of the Expenses (in $) in Korea (Republic) in 2005 to that in 2010?
Make the answer very short. 1.04. What is the ratio of the Expenses (in $) of Malta in 2005 to that in 2010?
Your answer should be compact. 1.43. What is the ratio of the Expenses (in $) in Morocco in 2005 to that in 2010?
Give a very brief answer. 0.25. What is the ratio of the Expenses (in $) in India in 2005 to that in 2011?
Keep it short and to the point. 3.88. What is the ratio of the Expenses (in $) of Korea (Republic) in 2005 to that in 2011?
Offer a terse response. 0.98. What is the ratio of the Expenses (in $) of Malta in 2005 to that in 2011?
Make the answer very short. 1.72. What is the ratio of the Expenses (in $) in Morocco in 2005 to that in 2011?
Provide a short and direct response. 0.31. What is the ratio of the Expenses (in $) of India in 2006 to that in 2007?
Give a very brief answer. 7.84. What is the ratio of the Expenses (in $) in Korea (Republic) in 2006 to that in 2007?
Your response must be concise. 1.34. What is the ratio of the Expenses (in $) in Malta in 2006 to that in 2007?
Offer a terse response. 0.95. What is the ratio of the Expenses (in $) of Morocco in 2006 to that in 2007?
Make the answer very short. 0.87. What is the ratio of the Expenses (in $) of India in 2006 to that in 2008?
Ensure brevity in your answer.  5.89. What is the ratio of the Expenses (in $) of Korea (Republic) in 2006 to that in 2008?
Your response must be concise. 1.14. What is the ratio of the Expenses (in $) of Malta in 2006 to that in 2008?
Provide a short and direct response. 2.16. What is the ratio of the Expenses (in $) of Morocco in 2006 to that in 2008?
Your answer should be very brief. 0.78. What is the ratio of the Expenses (in $) in India in 2006 to that in 2009?
Your answer should be compact. 3.23. What is the ratio of the Expenses (in $) of Korea (Republic) in 2006 to that in 2009?
Provide a succinct answer. 0.93. What is the ratio of the Expenses (in $) of Malta in 2006 to that in 2009?
Provide a succinct answer. 1.93. What is the ratio of the Expenses (in $) of Morocco in 2006 to that in 2009?
Your response must be concise. 0.56. What is the ratio of the Expenses (in $) in India in 2006 to that in 2010?
Your response must be concise. 3.37. What is the ratio of the Expenses (in $) in Korea (Republic) in 2006 to that in 2010?
Keep it short and to the point. 1.08. What is the ratio of the Expenses (in $) of Malta in 2006 to that in 2010?
Your response must be concise. 1.55. What is the ratio of the Expenses (in $) in Morocco in 2006 to that in 2010?
Your response must be concise. 0.44. What is the ratio of the Expenses (in $) of India in 2006 to that in 2011?
Keep it short and to the point. 3.37. What is the ratio of the Expenses (in $) in Korea (Republic) in 2006 to that in 2011?
Offer a terse response. 1.01. What is the ratio of the Expenses (in $) of Malta in 2006 to that in 2011?
Offer a very short reply. 1.87. What is the ratio of the Expenses (in $) of Morocco in 2006 to that in 2011?
Make the answer very short. 0.55. What is the ratio of the Expenses (in $) in India in 2007 to that in 2008?
Make the answer very short. 0.75. What is the ratio of the Expenses (in $) in Korea (Republic) in 2007 to that in 2008?
Keep it short and to the point. 0.85. What is the ratio of the Expenses (in $) in Malta in 2007 to that in 2008?
Ensure brevity in your answer.  2.27. What is the ratio of the Expenses (in $) in Morocco in 2007 to that in 2008?
Your response must be concise. 0.9. What is the ratio of the Expenses (in $) of India in 2007 to that in 2009?
Keep it short and to the point. 0.41. What is the ratio of the Expenses (in $) in Korea (Republic) in 2007 to that in 2009?
Your answer should be compact. 0.69. What is the ratio of the Expenses (in $) in Malta in 2007 to that in 2009?
Offer a very short reply. 2.02. What is the ratio of the Expenses (in $) in Morocco in 2007 to that in 2009?
Your answer should be very brief. 0.64. What is the ratio of the Expenses (in $) in India in 2007 to that in 2010?
Your answer should be compact. 0.43. What is the ratio of the Expenses (in $) in Korea (Republic) in 2007 to that in 2010?
Give a very brief answer. 0.8. What is the ratio of the Expenses (in $) in Malta in 2007 to that in 2010?
Your answer should be compact. 1.63. What is the ratio of the Expenses (in $) of Morocco in 2007 to that in 2010?
Keep it short and to the point. 0.51. What is the ratio of the Expenses (in $) of India in 2007 to that in 2011?
Your response must be concise. 0.43. What is the ratio of the Expenses (in $) in Korea (Republic) in 2007 to that in 2011?
Your response must be concise. 0.75. What is the ratio of the Expenses (in $) of Malta in 2007 to that in 2011?
Give a very brief answer. 1.96. What is the ratio of the Expenses (in $) of Morocco in 2007 to that in 2011?
Your response must be concise. 0.64. What is the ratio of the Expenses (in $) in India in 2008 to that in 2009?
Your response must be concise. 0.55. What is the ratio of the Expenses (in $) in Korea (Republic) in 2008 to that in 2009?
Your response must be concise. 0.81. What is the ratio of the Expenses (in $) of Malta in 2008 to that in 2009?
Your response must be concise. 0.89. What is the ratio of the Expenses (in $) in Morocco in 2008 to that in 2009?
Your response must be concise. 0.72. What is the ratio of the Expenses (in $) of India in 2008 to that in 2010?
Provide a succinct answer. 0.57. What is the ratio of the Expenses (in $) of Korea (Republic) in 2008 to that in 2010?
Ensure brevity in your answer.  0.94. What is the ratio of the Expenses (in $) of Malta in 2008 to that in 2010?
Provide a succinct answer. 0.72. What is the ratio of the Expenses (in $) in Morocco in 2008 to that in 2010?
Your answer should be compact. 0.57. What is the ratio of the Expenses (in $) of India in 2008 to that in 2011?
Your answer should be compact. 0.57. What is the ratio of the Expenses (in $) in Korea (Republic) in 2008 to that in 2011?
Provide a short and direct response. 0.88. What is the ratio of the Expenses (in $) in Malta in 2008 to that in 2011?
Your answer should be very brief. 0.86. What is the ratio of the Expenses (in $) of Morocco in 2008 to that in 2011?
Give a very brief answer. 0.71. What is the ratio of the Expenses (in $) of India in 2009 to that in 2010?
Your response must be concise. 1.04. What is the ratio of the Expenses (in $) of Korea (Republic) in 2009 to that in 2010?
Keep it short and to the point. 1.16. What is the ratio of the Expenses (in $) in Malta in 2009 to that in 2010?
Your answer should be very brief. 0.81. What is the ratio of the Expenses (in $) of Morocco in 2009 to that in 2010?
Give a very brief answer. 0.79. What is the ratio of the Expenses (in $) in India in 2009 to that in 2011?
Your response must be concise. 1.04. What is the ratio of the Expenses (in $) in Korea (Republic) in 2009 to that in 2011?
Give a very brief answer. 1.09. What is the ratio of the Expenses (in $) in Malta in 2009 to that in 2011?
Your answer should be compact. 0.97. What is the ratio of the Expenses (in $) of India in 2010 to that in 2011?
Ensure brevity in your answer.  1. What is the ratio of the Expenses (in $) of Korea (Republic) in 2010 to that in 2011?
Provide a succinct answer. 0.94. What is the ratio of the Expenses (in $) in Malta in 2010 to that in 2011?
Provide a succinct answer. 1.2. What is the ratio of the Expenses (in $) in Morocco in 2010 to that in 2011?
Offer a very short reply. 1.25. What is the difference between the highest and the second highest Expenses (in $) of India?
Provide a short and direct response. 4.53e+1. What is the difference between the highest and the second highest Expenses (in $) in Korea (Republic)?
Provide a succinct answer. 2.81e+12. What is the difference between the highest and the second highest Expenses (in $) of Malta?
Ensure brevity in your answer.  2.38e+07. What is the difference between the highest and the second highest Expenses (in $) of Morocco?
Give a very brief answer. 6.84e+09. What is the difference between the highest and the lowest Expenses (in $) of India?
Your response must be concise. 3.09e+11. What is the difference between the highest and the lowest Expenses (in $) in Korea (Republic)?
Offer a terse response. 1.22e+13. What is the difference between the highest and the lowest Expenses (in $) in Malta?
Your answer should be compact. 2.79e+08. What is the difference between the highest and the lowest Expenses (in $) in Morocco?
Provide a succinct answer. 3.27e+1. 